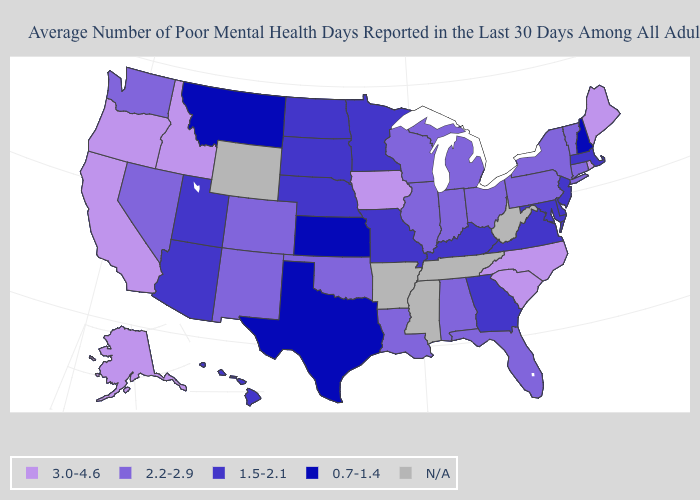Name the states that have a value in the range 0.7-1.4?
Answer briefly. Kansas, Montana, New Hampshire, Texas. Which states hav the highest value in the MidWest?
Short answer required. Iowa. Which states have the lowest value in the USA?
Write a very short answer. Kansas, Montana, New Hampshire, Texas. What is the value of Idaho?
Quick response, please. 3.0-4.6. Does the first symbol in the legend represent the smallest category?
Short answer required. No. Name the states that have a value in the range 0.7-1.4?
Be succinct. Kansas, Montana, New Hampshire, Texas. What is the value of West Virginia?
Quick response, please. N/A. What is the lowest value in the MidWest?
Give a very brief answer. 0.7-1.4. What is the value of Idaho?
Concise answer only. 3.0-4.6. Among the states that border Tennessee , does North Carolina have the highest value?
Short answer required. Yes. Does the map have missing data?
Answer briefly. Yes. Name the states that have a value in the range 3.0-4.6?
Be succinct. Alaska, California, Idaho, Iowa, Maine, North Carolina, Oregon, Rhode Island, South Carolina. 